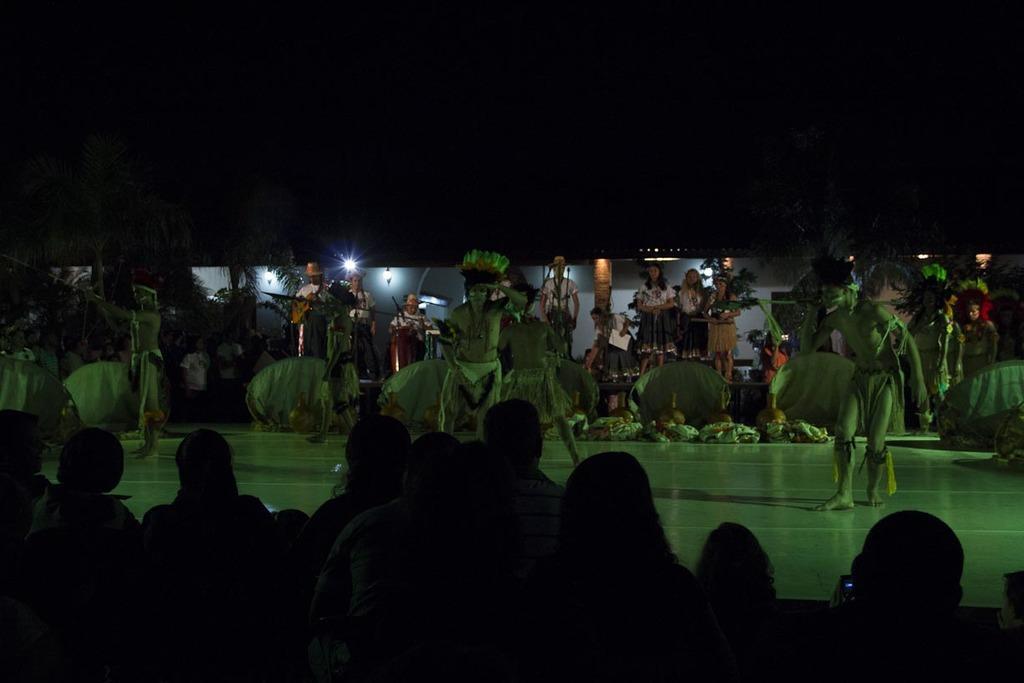Could you give a brief overview of what you see in this image? This image is taken during the night time. In this image there are few persons standing on the floor and dancing by wearing different costumes. There are so many spectators around them who are watching the dance. In the background there is a house to which there are lights and pillars. 